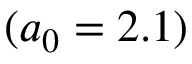Convert formula to latex. <formula><loc_0><loc_0><loc_500><loc_500>( a _ { 0 } = 2 . 1 )</formula> 